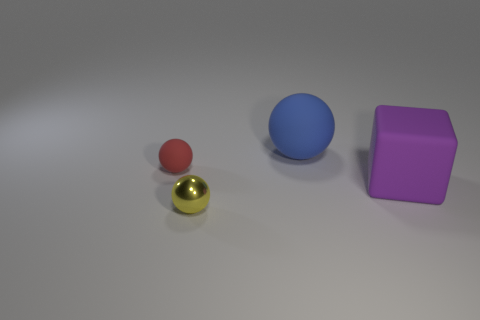What number of other objects are the same shape as the big blue object?
Offer a terse response. 2. Is there any other thing of the same color as the block?
Make the answer very short. No. Is the number of purple things greater than the number of tiny brown matte cylinders?
Provide a short and direct response. Yes. Is the large sphere made of the same material as the large purple cube?
Your answer should be compact. Yes. How many large blocks have the same material as the small red ball?
Your response must be concise. 1. Does the purple matte thing have the same size as the matte object that is to the left of the blue thing?
Provide a succinct answer. No. What is the color of the thing that is both in front of the small red sphere and right of the tiny yellow metal sphere?
Your answer should be compact. Purple. There is a object in front of the big purple rubber thing; are there any things on the right side of it?
Give a very brief answer. Yes. Are there the same number of tiny shiny things that are to the right of the small metal ball and big blue things?
Your response must be concise. No. There is a small red sphere that is in front of the matte ball that is behind the tiny red sphere; how many big purple rubber blocks are behind it?
Make the answer very short. 0. 